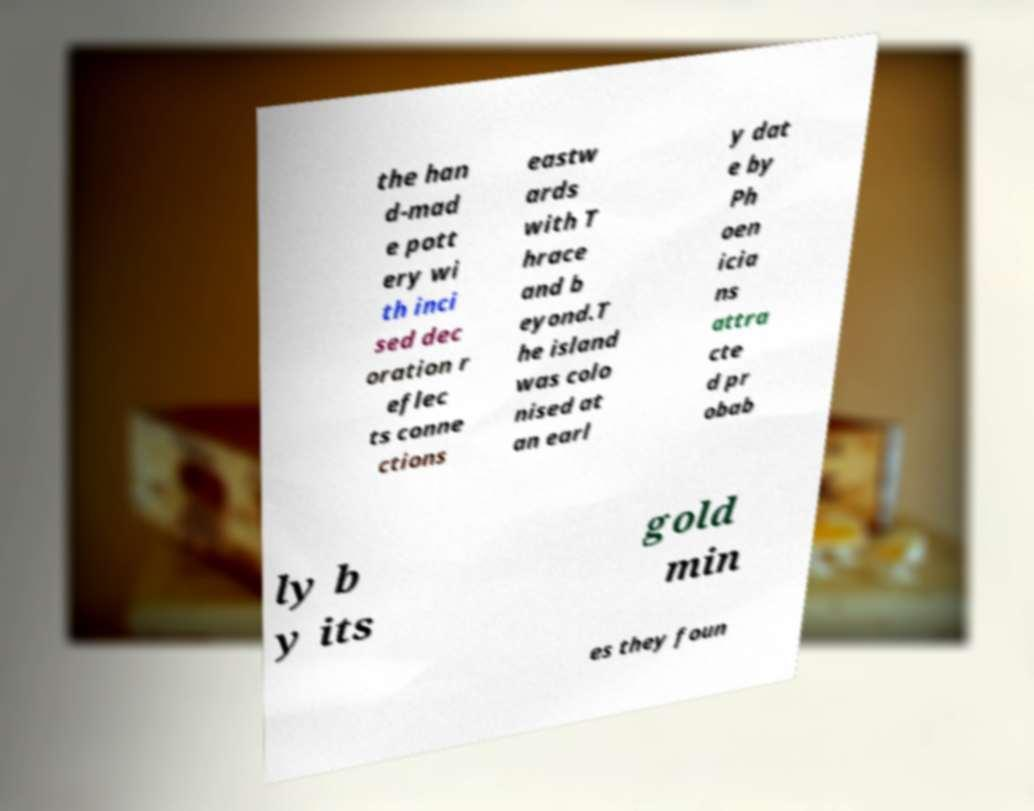Please identify and transcribe the text found in this image. the han d-mad e pott ery wi th inci sed dec oration r eflec ts conne ctions eastw ards with T hrace and b eyond.T he island was colo nised at an earl y dat e by Ph oen icia ns attra cte d pr obab ly b y its gold min es they foun 